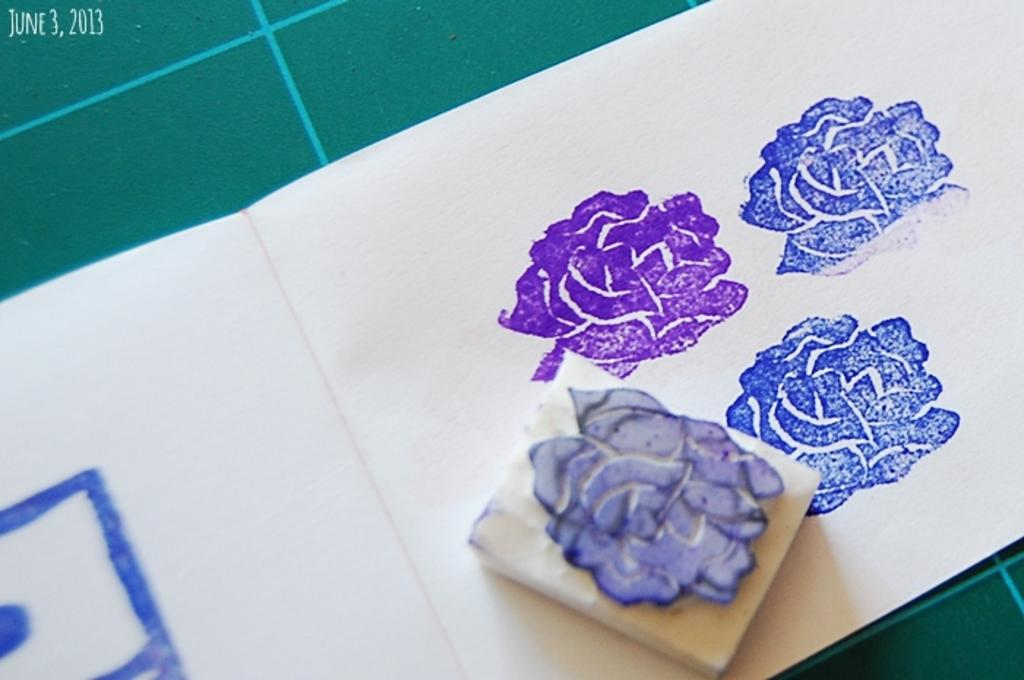What is the color of the mat in the image? The mat in the image is green. What is the color of the paper in the image? The paper in the image is white. What is depicted on the white paper? The white paper has printed flowers on it. What type of produce is being cooked on the stove in the image? There is no stove or produce present in the image. How many ice cubes are visible in the image? There are no ice cubes present in the image. 